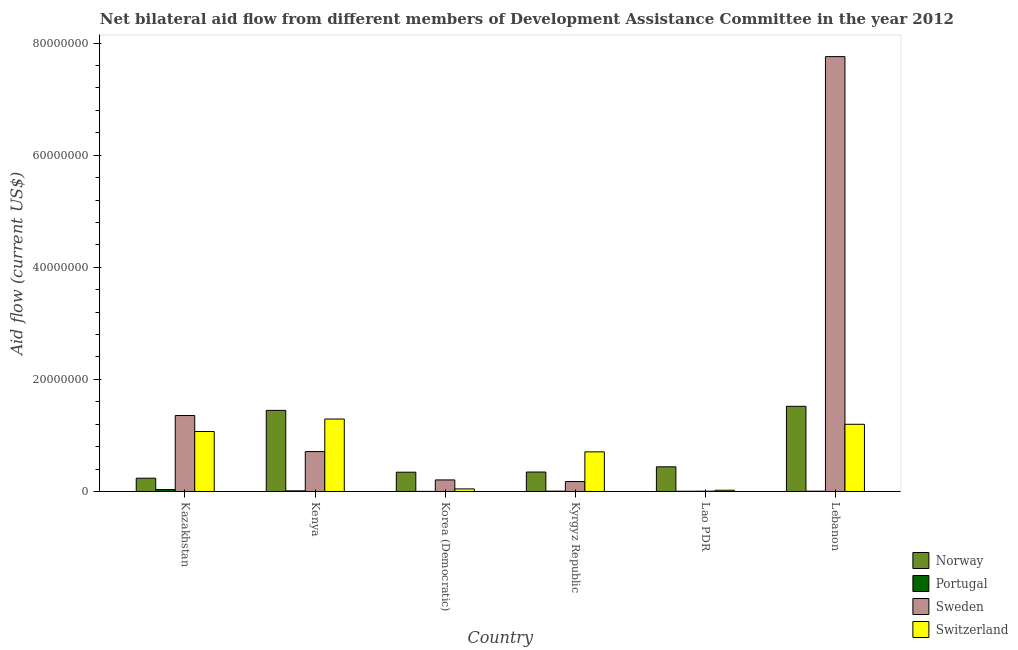Are the number of bars per tick equal to the number of legend labels?
Make the answer very short. Yes. How many bars are there on the 6th tick from the left?
Offer a terse response. 4. How many bars are there on the 5th tick from the right?
Your answer should be compact. 4. What is the label of the 4th group of bars from the left?
Ensure brevity in your answer.  Kyrgyz Republic. In how many cases, is the number of bars for a given country not equal to the number of legend labels?
Give a very brief answer. 0. What is the amount of aid given by sweden in Korea (Democratic)?
Give a very brief answer. 2.06e+06. Across all countries, what is the maximum amount of aid given by sweden?
Keep it short and to the point. 7.76e+07. Across all countries, what is the minimum amount of aid given by portugal?
Your answer should be compact. 10000. In which country was the amount of aid given by portugal maximum?
Keep it short and to the point. Kazakhstan. In which country was the amount of aid given by norway minimum?
Ensure brevity in your answer.  Kazakhstan. What is the total amount of aid given by sweden in the graph?
Offer a very short reply. 1.02e+08. What is the difference between the amount of aid given by portugal in Kenya and that in Kyrgyz Republic?
Your response must be concise. 5.00e+04. What is the difference between the amount of aid given by portugal in Kazakhstan and the amount of aid given by sweden in Kyrgyz Republic?
Offer a terse response. -1.43e+06. What is the average amount of aid given by sweden per country?
Make the answer very short. 1.70e+07. What is the difference between the amount of aid given by sweden and amount of aid given by switzerland in Kazakhstan?
Offer a very short reply. 2.85e+06. What is the ratio of the amount of aid given by norway in Kyrgyz Republic to that in Lebanon?
Your answer should be very brief. 0.23. Is the amount of aid given by sweden in Kazakhstan less than that in Lao PDR?
Give a very brief answer. No. What is the difference between the highest and the lowest amount of aid given by norway?
Offer a terse response. 1.28e+07. In how many countries, is the amount of aid given by switzerland greater than the average amount of aid given by switzerland taken over all countries?
Your response must be concise. 3. Is it the case that in every country, the sum of the amount of aid given by switzerland and amount of aid given by sweden is greater than the sum of amount of aid given by norway and amount of aid given by portugal?
Provide a succinct answer. No. What does the 2nd bar from the right in Lao PDR represents?
Provide a short and direct response. Sweden. How many bars are there?
Keep it short and to the point. 24. Are all the bars in the graph horizontal?
Offer a terse response. No. How many countries are there in the graph?
Keep it short and to the point. 6. Are the values on the major ticks of Y-axis written in scientific E-notation?
Your answer should be very brief. No. Does the graph contain any zero values?
Give a very brief answer. No. Does the graph contain grids?
Give a very brief answer. No. Where does the legend appear in the graph?
Your answer should be very brief. Bottom right. How are the legend labels stacked?
Provide a succinct answer. Vertical. What is the title of the graph?
Your answer should be very brief. Net bilateral aid flow from different members of Development Assistance Committee in the year 2012. What is the Aid flow (current US$) in Norway in Kazakhstan?
Keep it short and to the point. 2.37e+06. What is the Aid flow (current US$) of Sweden in Kazakhstan?
Offer a terse response. 1.36e+07. What is the Aid flow (current US$) of Switzerland in Kazakhstan?
Provide a succinct answer. 1.07e+07. What is the Aid flow (current US$) in Norway in Kenya?
Provide a short and direct response. 1.45e+07. What is the Aid flow (current US$) of Sweden in Kenya?
Your answer should be very brief. 7.12e+06. What is the Aid flow (current US$) of Switzerland in Kenya?
Provide a succinct answer. 1.29e+07. What is the Aid flow (current US$) of Norway in Korea (Democratic)?
Provide a short and direct response. 3.44e+06. What is the Aid flow (current US$) of Sweden in Korea (Democratic)?
Provide a succinct answer. 2.06e+06. What is the Aid flow (current US$) in Switzerland in Korea (Democratic)?
Offer a terse response. 4.60e+05. What is the Aid flow (current US$) in Norway in Kyrgyz Republic?
Make the answer very short. 3.47e+06. What is the Aid flow (current US$) in Sweden in Kyrgyz Republic?
Provide a short and direct response. 1.77e+06. What is the Aid flow (current US$) of Switzerland in Kyrgyz Republic?
Keep it short and to the point. 7.07e+06. What is the Aid flow (current US$) of Norway in Lao PDR?
Offer a terse response. 4.40e+06. What is the Aid flow (current US$) of Sweden in Lao PDR?
Give a very brief answer. 5.00e+04. What is the Aid flow (current US$) in Norway in Lebanon?
Your response must be concise. 1.52e+07. What is the Aid flow (current US$) in Sweden in Lebanon?
Offer a very short reply. 7.76e+07. What is the Aid flow (current US$) of Switzerland in Lebanon?
Make the answer very short. 1.20e+07. Across all countries, what is the maximum Aid flow (current US$) of Norway?
Offer a terse response. 1.52e+07. Across all countries, what is the maximum Aid flow (current US$) of Sweden?
Ensure brevity in your answer.  7.76e+07. Across all countries, what is the maximum Aid flow (current US$) in Switzerland?
Give a very brief answer. 1.29e+07. Across all countries, what is the minimum Aid flow (current US$) in Norway?
Your answer should be very brief. 2.37e+06. Across all countries, what is the minimum Aid flow (current US$) in Sweden?
Provide a succinct answer. 5.00e+04. Across all countries, what is the minimum Aid flow (current US$) of Switzerland?
Your response must be concise. 2.20e+05. What is the total Aid flow (current US$) of Norway in the graph?
Make the answer very short. 4.34e+07. What is the total Aid flow (current US$) of Sweden in the graph?
Provide a succinct answer. 1.02e+08. What is the total Aid flow (current US$) in Switzerland in the graph?
Your answer should be very brief. 4.34e+07. What is the difference between the Aid flow (current US$) of Norway in Kazakhstan and that in Kenya?
Provide a succinct answer. -1.21e+07. What is the difference between the Aid flow (current US$) in Portugal in Kazakhstan and that in Kenya?
Make the answer very short. 2.30e+05. What is the difference between the Aid flow (current US$) of Sweden in Kazakhstan and that in Kenya?
Your answer should be compact. 6.43e+06. What is the difference between the Aid flow (current US$) in Switzerland in Kazakhstan and that in Kenya?
Make the answer very short. -2.23e+06. What is the difference between the Aid flow (current US$) in Norway in Kazakhstan and that in Korea (Democratic)?
Keep it short and to the point. -1.07e+06. What is the difference between the Aid flow (current US$) in Portugal in Kazakhstan and that in Korea (Democratic)?
Give a very brief answer. 3.30e+05. What is the difference between the Aid flow (current US$) of Sweden in Kazakhstan and that in Korea (Democratic)?
Provide a short and direct response. 1.15e+07. What is the difference between the Aid flow (current US$) of Switzerland in Kazakhstan and that in Korea (Democratic)?
Your response must be concise. 1.02e+07. What is the difference between the Aid flow (current US$) of Norway in Kazakhstan and that in Kyrgyz Republic?
Give a very brief answer. -1.10e+06. What is the difference between the Aid flow (current US$) in Portugal in Kazakhstan and that in Kyrgyz Republic?
Your answer should be very brief. 2.80e+05. What is the difference between the Aid flow (current US$) in Sweden in Kazakhstan and that in Kyrgyz Republic?
Ensure brevity in your answer.  1.18e+07. What is the difference between the Aid flow (current US$) in Switzerland in Kazakhstan and that in Kyrgyz Republic?
Offer a terse response. 3.63e+06. What is the difference between the Aid flow (current US$) in Norway in Kazakhstan and that in Lao PDR?
Offer a terse response. -2.03e+06. What is the difference between the Aid flow (current US$) of Portugal in Kazakhstan and that in Lao PDR?
Your response must be concise. 3.00e+05. What is the difference between the Aid flow (current US$) of Sweden in Kazakhstan and that in Lao PDR?
Provide a short and direct response. 1.35e+07. What is the difference between the Aid flow (current US$) in Switzerland in Kazakhstan and that in Lao PDR?
Offer a terse response. 1.05e+07. What is the difference between the Aid flow (current US$) of Norway in Kazakhstan and that in Lebanon?
Provide a short and direct response. -1.28e+07. What is the difference between the Aid flow (current US$) in Sweden in Kazakhstan and that in Lebanon?
Offer a very short reply. -6.40e+07. What is the difference between the Aid flow (current US$) in Switzerland in Kazakhstan and that in Lebanon?
Ensure brevity in your answer.  -1.29e+06. What is the difference between the Aid flow (current US$) in Norway in Kenya and that in Korea (Democratic)?
Your response must be concise. 1.10e+07. What is the difference between the Aid flow (current US$) of Portugal in Kenya and that in Korea (Democratic)?
Ensure brevity in your answer.  1.00e+05. What is the difference between the Aid flow (current US$) in Sweden in Kenya and that in Korea (Democratic)?
Your answer should be very brief. 5.06e+06. What is the difference between the Aid flow (current US$) of Switzerland in Kenya and that in Korea (Democratic)?
Offer a very short reply. 1.25e+07. What is the difference between the Aid flow (current US$) of Norway in Kenya and that in Kyrgyz Republic?
Offer a very short reply. 1.10e+07. What is the difference between the Aid flow (current US$) in Sweden in Kenya and that in Kyrgyz Republic?
Make the answer very short. 5.35e+06. What is the difference between the Aid flow (current US$) of Switzerland in Kenya and that in Kyrgyz Republic?
Make the answer very short. 5.86e+06. What is the difference between the Aid flow (current US$) of Norway in Kenya and that in Lao PDR?
Provide a succinct answer. 1.01e+07. What is the difference between the Aid flow (current US$) of Portugal in Kenya and that in Lao PDR?
Your answer should be compact. 7.00e+04. What is the difference between the Aid flow (current US$) in Sweden in Kenya and that in Lao PDR?
Your answer should be very brief. 7.07e+06. What is the difference between the Aid flow (current US$) of Switzerland in Kenya and that in Lao PDR?
Keep it short and to the point. 1.27e+07. What is the difference between the Aid flow (current US$) of Norway in Kenya and that in Lebanon?
Offer a very short reply. -7.30e+05. What is the difference between the Aid flow (current US$) of Sweden in Kenya and that in Lebanon?
Provide a succinct answer. -7.05e+07. What is the difference between the Aid flow (current US$) in Switzerland in Kenya and that in Lebanon?
Provide a short and direct response. 9.40e+05. What is the difference between the Aid flow (current US$) in Switzerland in Korea (Democratic) and that in Kyrgyz Republic?
Provide a succinct answer. -6.61e+06. What is the difference between the Aid flow (current US$) in Norway in Korea (Democratic) and that in Lao PDR?
Keep it short and to the point. -9.60e+05. What is the difference between the Aid flow (current US$) in Portugal in Korea (Democratic) and that in Lao PDR?
Provide a short and direct response. -3.00e+04. What is the difference between the Aid flow (current US$) in Sweden in Korea (Democratic) and that in Lao PDR?
Your answer should be very brief. 2.01e+06. What is the difference between the Aid flow (current US$) in Norway in Korea (Democratic) and that in Lebanon?
Offer a very short reply. -1.18e+07. What is the difference between the Aid flow (current US$) of Sweden in Korea (Democratic) and that in Lebanon?
Give a very brief answer. -7.55e+07. What is the difference between the Aid flow (current US$) of Switzerland in Korea (Democratic) and that in Lebanon?
Give a very brief answer. -1.15e+07. What is the difference between the Aid flow (current US$) of Norway in Kyrgyz Republic and that in Lao PDR?
Your response must be concise. -9.30e+05. What is the difference between the Aid flow (current US$) in Portugal in Kyrgyz Republic and that in Lao PDR?
Your answer should be compact. 2.00e+04. What is the difference between the Aid flow (current US$) in Sweden in Kyrgyz Republic and that in Lao PDR?
Your response must be concise. 1.72e+06. What is the difference between the Aid flow (current US$) in Switzerland in Kyrgyz Republic and that in Lao PDR?
Your answer should be very brief. 6.85e+06. What is the difference between the Aid flow (current US$) in Norway in Kyrgyz Republic and that in Lebanon?
Provide a short and direct response. -1.17e+07. What is the difference between the Aid flow (current US$) in Sweden in Kyrgyz Republic and that in Lebanon?
Keep it short and to the point. -7.58e+07. What is the difference between the Aid flow (current US$) of Switzerland in Kyrgyz Republic and that in Lebanon?
Your answer should be compact. -4.92e+06. What is the difference between the Aid flow (current US$) of Norway in Lao PDR and that in Lebanon?
Keep it short and to the point. -1.08e+07. What is the difference between the Aid flow (current US$) of Sweden in Lao PDR and that in Lebanon?
Your answer should be compact. -7.76e+07. What is the difference between the Aid flow (current US$) of Switzerland in Lao PDR and that in Lebanon?
Your answer should be very brief. -1.18e+07. What is the difference between the Aid flow (current US$) of Norway in Kazakhstan and the Aid flow (current US$) of Portugal in Kenya?
Make the answer very short. 2.26e+06. What is the difference between the Aid flow (current US$) in Norway in Kazakhstan and the Aid flow (current US$) in Sweden in Kenya?
Your response must be concise. -4.75e+06. What is the difference between the Aid flow (current US$) in Norway in Kazakhstan and the Aid flow (current US$) in Switzerland in Kenya?
Give a very brief answer. -1.06e+07. What is the difference between the Aid flow (current US$) in Portugal in Kazakhstan and the Aid flow (current US$) in Sweden in Kenya?
Keep it short and to the point. -6.78e+06. What is the difference between the Aid flow (current US$) of Portugal in Kazakhstan and the Aid flow (current US$) of Switzerland in Kenya?
Provide a succinct answer. -1.26e+07. What is the difference between the Aid flow (current US$) of Sweden in Kazakhstan and the Aid flow (current US$) of Switzerland in Kenya?
Make the answer very short. 6.20e+05. What is the difference between the Aid flow (current US$) in Norway in Kazakhstan and the Aid flow (current US$) in Portugal in Korea (Democratic)?
Your response must be concise. 2.36e+06. What is the difference between the Aid flow (current US$) of Norway in Kazakhstan and the Aid flow (current US$) of Switzerland in Korea (Democratic)?
Your answer should be compact. 1.91e+06. What is the difference between the Aid flow (current US$) in Portugal in Kazakhstan and the Aid flow (current US$) in Sweden in Korea (Democratic)?
Provide a short and direct response. -1.72e+06. What is the difference between the Aid flow (current US$) in Portugal in Kazakhstan and the Aid flow (current US$) in Switzerland in Korea (Democratic)?
Provide a succinct answer. -1.20e+05. What is the difference between the Aid flow (current US$) in Sweden in Kazakhstan and the Aid flow (current US$) in Switzerland in Korea (Democratic)?
Provide a succinct answer. 1.31e+07. What is the difference between the Aid flow (current US$) of Norway in Kazakhstan and the Aid flow (current US$) of Portugal in Kyrgyz Republic?
Keep it short and to the point. 2.31e+06. What is the difference between the Aid flow (current US$) of Norway in Kazakhstan and the Aid flow (current US$) of Switzerland in Kyrgyz Republic?
Make the answer very short. -4.70e+06. What is the difference between the Aid flow (current US$) of Portugal in Kazakhstan and the Aid flow (current US$) of Sweden in Kyrgyz Republic?
Your response must be concise. -1.43e+06. What is the difference between the Aid flow (current US$) of Portugal in Kazakhstan and the Aid flow (current US$) of Switzerland in Kyrgyz Republic?
Your answer should be very brief. -6.73e+06. What is the difference between the Aid flow (current US$) in Sweden in Kazakhstan and the Aid flow (current US$) in Switzerland in Kyrgyz Republic?
Give a very brief answer. 6.48e+06. What is the difference between the Aid flow (current US$) of Norway in Kazakhstan and the Aid flow (current US$) of Portugal in Lao PDR?
Your response must be concise. 2.33e+06. What is the difference between the Aid flow (current US$) of Norway in Kazakhstan and the Aid flow (current US$) of Sweden in Lao PDR?
Keep it short and to the point. 2.32e+06. What is the difference between the Aid flow (current US$) of Norway in Kazakhstan and the Aid flow (current US$) of Switzerland in Lao PDR?
Ensure brevity in your answer.  2.15e+06. What is the difference between the Aid flow (current US$) in Portugal in Kazakhstan and the Aid flow (current US$) in Sweden in Lao PDR?
Your response must be concise. 2.90e+05. What is the difference between the Aid flow (current US$) in Sweden in Kazakhstan and the Aid flow (current US$) in Switzerland in Lao PDR?
Make the answer very short. 1.33e+07. What is the difference between the Aid flow (current US$) in Norway in Kazakhstan and the Aid flow (current US$) in Portugal in Lebanon?
Offer a very short reply. 2.32e+06. What is the difference between the Aid flow (current US$) in Norway in Kazakhstan and the Aid flow (current US$) in Sweden in Lebanon?
Make the answer very short. -7.52e+07. What is the difference between the Aid flow (current US$) of Norway in Kazakhstan and the Aid flow (current US$) of Switzerland in Lebanon?
Your answer should be very brief. -9.62e+06. What is the difference between the Aid flow (current US$) in Portugal in Kazakhstan and the Aid flow (current US$) in Sweden in Lebanon?
Ensure brevity in your answer.  -7.73e+07. What is the difference between the Aid flow (current US$) of Portugal in Kazakhstan and the Aid flow (current US$) of Switzerland in Lebanon?
Give a very brief answer. -1.16e+07. What is the difference between the Aid flow (current US$) in Sweden in Kazakhstan and the Aid flow (current US$) in Switzerland in Lebanon?
Offer a very short reply. 1.56e+06. What is the difference between the Aid flow (current US$) of Norway in Kenya and the Aid flow (current US$) of Portugal in Korea (Democratic)?
Keep it short and to the point. 1.45e+07. What is the difference between the Aid flow (current US$) of Norway in Kenya and the Aid flow (current US$) of Sweden in Korea (Democratic)?
Your answer should be very brief. 1.24e+07. What is the difference between the Aid flow (current US$) of Norway in Kenya and the Aid flow (current US$) of Switzerland in Korea (Democratic)?
Offer a terse response. 1.40e+07. What is the difference between the Aid flow (current US$) in Portugal in Kenya and the Aid flow (current US$) in Sweden in Korea (Democratic)?
Provide a short and direct response. -1.95e+06. What is the difference between the Aid flow (current US$) of Portugal in Kenya and the Aid flow (current US$) of Switzerland in Korea (Democratic)?
Keep it short and to the point. -3.50e+05. What is the difference between the Aid flow (current US$) in Sweden in Kenya and the Aid flow (current US$) in Switzerland in Korea (Democratic)?
Keep it short and to the point. 6.66e+06. What is the difference between the Aid flow (current US$) of Norway in Kenya and the Aid flow (current US$) of Portugal in Kyrgyz Republic?
Provide a succinct answer. 1.44e+07. What is the difference between the Aid flow (current US$) of Norway in Kenya and the Aid flow (current US$) of Sweden in Kyrgyz Republic?
Offer a very short reply. 1.27e+07. What is the difference between the Aid flow (current US$) of Norway in Kenya and the Aid flow (current US$) of Switzerland in Kyrgyz Republic?
Your response must be concise. 7.40e+06. What is the difference between the Aid flow (current US$) in Portugal in Kenya and the Aid flow (current US$) in Sweden in Kyrgyz Republic?
Make the answer very short. -1.66e+06. What is the difference between the Aid flow (current US$) in Portugal in Kenya and the Aid flow (current US$) in Switzerland in Kyrgyz Republic?
Provide a short and direct response. -6.96e+06. What is the difference between the Aid flow (current US$) in Norway in Kenya and the Aid flow (current US$) in Portugal in Lao PDR?
Your answer should be very brief. 1.44e+07. What is the difference between the Aid flow (current US$) of Norway in Kenya and the Aid flow (current US$) of Sweden in Lao PDR?
Provide a short and direct response. 1.44e+07. What is the difference between the Aid flow (current US$) of Norway in Kenya and the Aid flow (current US$) of Switzerland in Lao PDR?
Offer a terse response. 1.42e+07. What is the difference between the Aid flow (current US$) of Portugal in Kenya and the Aid flow (current US$) of Switzerland in Lao PDR?
Provide a short and direct response. -1.10e+05. What is the difference between the Aid flow (current US$) in Sweden in Kenya and the Aid flow (current US$) in Switzerland in Lao PDR?
Your response must be concise. 6.90e+06. What is the difference between the Aid flow (current US$) in Norway in Kenya and the Aid flow (current US$) in Portugal in Lebanon?
Ensure brevity in your answer.  1.44e+07. What is the difference between the Aid flow (current US$) in Norway in Kenya and the Aid flow (current US$) in Sweden in Lebanon?
Your answer should be very brief. -6.31e+07. What is the difference between the Aid flow (current US$) in Norway in Kenya and the Aid flow (current US$) in Switzerland in Lebanon?
Your response must be concise. 2.48e+06. What is the difference between the Aid flow (current US$) in Portugal in Kenya and the Aid flow (current US$) in Sweden in Lebanon?
Keep it short and to the point. -7.75e+07. What is the difference between the Aid flow (current US$) of Portugal in Kenya and the Aid flow (current US$) of Switzerland in Lebanon?
Offer a very short reply. -1.19e+07. What is the difference between the Aid flow (current US$) of Sweden in Kenya and the Aid flow (current US$) of Switzerland in Lebanon?
Give a very brief answer. -4.87e+06. What is the difference between the Aid flow (current US$) of Norway in Korea (Democratic) and the Aid flow (current US$) of Portugal in Kyrgyz Republic?
Offer a terse response. 3.38e+06. What is the difference between the Aid flow (current US$) of Norway in Korea (Democratic) and the Aid flow (current US$) of Sweden in Kyrgyz Republic?
Offer a terse response. 1.67e+06. What is the difference between the Aid flow (current US$) of Norway in Korea (Democratic) and the Aid flow (current US$) of Switzerland in Kyrgyz Republic?
Offer a terse response. -3.63e+06. What is the difference between the Aid flow (current US$) in Portugal in Korea (Democratic) and the Aid flow (current US$) in Sweden in Kyrgyz Republic?
Keep it short and to the point. -1.76e+06. What is the difference between the Aid flow (current US$) in Portugal in Korea (Democratic) and the Aid flow (current US$) in Switzerland in Kyrgyz Republic?
Provide a succinct answer. -7.06e+06. What is the difference between the Aid flow (current US$) of Sweden in Korea (Democratic) and the Aid flow (current US$) of Switzerland in Kyrgyz Republic?
Your answer should be compact. -5.01e+06. What is the difference between the Aid flow (current US$) in Norway in Korea (Democratic) and the Aid flow (current US$) in Portugal in Lao PDR?
Offer a very short reply. 3.40e+06. What is the difference between the Aid flow (current US$) in Norway in Korea (Democratic) and the Aid flow (current US$) in Sweden in Lao PDR?
Offer a terse response. 3.39e+06. What is the difference between the Aid flow (current US$) in Norway in Korea (Democratic) and the Aid flow (current US$) in Switzerland in Lao PDR?
Your answer should be very brief. 3.22e+06. What is the difference between the Aid flow (current US$) in Portugal in Korea (Democratic) and the Aid flow (current US$) in Switzerland in Lao PDR?
Offer a very short reply. -2.10e+05. What is the difference between the Aid flow (current US$) of Sweden in Korea (Democratic) and the Aid flow (current US$) of Switzerland in Lao PDR?
Offer a terse response. 1.84e+06. What is the difference between the Aid flow (current US$) in Norway in Korea (Democratic) and the Aid flow (current US$) in Portugal in Lebanon?
Your answer should be very brief. 3.39e+06. What is the difference between the Aid flow (current US$) in Norway in Korea (Democratic) and the Aid flow (current US$) in Sweden in Lebanon?
Give a very brief answer. -7.42e+07. What is the difference between the Aid flow (current US$) of Norway in Korea (Democratic) and the Aid flow (current US$) of Switzerland in Lebanon?
Provide a succinct answer. -8.55e+06. What is the difference between the Aid flow (current US$) in Portugal in Korea (Democratic) and the Aid flow (current US$) in Sweden in Lebanon?
Your answer should be compact. -7.76e+07. What is the difference between the Aid flow (current US$) of Portugal in Korea (Democratic) and the Aid flow (current US$) of Switzerland in Lebanon?
Offer a terse response. -1.20e+07. What is the difference between the Aid flow (current US$) of Sweden in Korea (Democratic) and the Aid flow (current US$) of Switzerland in Lebanon?
Your answer should be very brief. -9.93e+06. What is the difference between the Aid flow (current US$) of Norway in Kyrgyz Republic and the Aid flow (current US$) of Portugal in Lao PDR?
Give a very brief answer. 3.43e+06. What is the difference between the Aid flow (current US$) in Norway in Kyrgyz Republic and the Aid flow (current US$) in Sweden in Lao PDR?
Your response must be concise. 3.42e+06. What is the difference between the Aid flow (current US$) of Norway in Kyrgyz Republic and the Aid flow (current US$) of Switzerland in Lao PDR?
Offer a very short reply. 3.25e+06. What is the difference between the Aid flow (current US$) of Portugal in Kyrgyz Republic and the Aid flow (current US$) of Sweden in Lao PDR?
Provide a short and direct response. 10000. What is the difference between the Aid flow (current US$) of Portugal in Kyrgyz Republic and the Aid flow (current US$) of Switzerland in Lao PDR?
Your answer should be compact. -1.60e+05. What is the difference between the Aid flow (current US$) in Sweden in Kyrgyz Republic and the Aid flow (current US$) in Switzerland in Lao PDR?
Ensure brevity in your answer.  1.55e+06. What is the difference between the Aid flow (current US$) in Norway in Kyrgyz Republic and the Aid flow (current US$) in Portugal in Lebanon?
Your response must be concise. 3.42e+06. What is the difference between the Aid flow (current US$) in Norway in Kyrgyz Republic and the Aid flow (current US$) in Sweden in Lebanon?
Provide a short and direct response. -7.41e+07. What is the difference between the Aid flow (current US$) of Norway in Kyrgyz Republic and the Aid flow (current US$) of Switzerland in Lebanon?
Ensure brevity in your answer.  -8.52e+06. What is the difference between the Aid flow (current US$) of Portugal in Kyrgyz Republic and the Aid flow (current US$) of Sweden in Lebanon?
Keep it short and to the point. -7.75e+07. What is the difference between the Aid flow (current US$) in Portugal in Kyrgyz Republic and the Aid flow (current US$) in Switzerland in Lebanon?
Your answer should be very brief. -1.19e+07. What is the difference between the Aid flow (current US$) of Sweden in Kyrgyz Republic and the Aid flow (current US$) of Switzerland in Lebanon?
Make the answer very short. -1.02e+07. What is the difference between the Aid flow (current US$) in Norway in Lao PDR and the Aid flow (current US$) in Portugal in Lebanon?
Offer a very short reply. 4.35e+06. What is the difference between the Aid flow (current US$) in Norway in Lao PDR and the Aid flow (current US$) in Sweden in Lebanon?
Offer a terse response. -7.32e+07. What is the difference between the Aid flow (current US$) in Norway in Lao PDR and the Aid flow (current US$) in Switzerland in Lebanon?
Your answer should be compact. -7.59e+06. What is the difference between the Aid flow (current US$) in Portugal in Lao PDR and the Aid flow (current US$) in Sweden in Lebanon?
Provide a short and direct response. -7.76e+07. What is the difference between the Aid flow (current US$) of Portugal in Lao PDR and the Aid flow (current US$) of Switzerland in Lebanon?
Offer a very short reply. -1.20e+07. What is the difference between the Aid flow (current US$) of Sweden in Lao PDR and the Aid flow (current US$) of Switzerland in Lebanon?
Ensure brevity in your answer.  -1.19e+07. What is the average Aid flow (current US$) in Norway per country?
Give a very brief answer. 7.22e+06. What is the average Aid flow (current US$) of Portugal per country?
Provide a succinct answer. 1.02e+05. What is the average Aid flow (current US$) in Sweden per country?
Provide a succinct answer. 1.70e+07. What is the average Aid flow (current US$) in Switzerland per country?
Your answer should be compact. 7.23e+06. What is the difference between the Aid flow (current US$) of Norway and Aid flow (current US$) of Portugal in Kazakhstan?
Offer a very short reply. 2.03e+06. What is the difference between the Aid flow (current US$) in Norway and Aid flow (current US$) in Sweden in Kazakhstan?
Your response must be concise. -1.12e+07. What is the difference between the Aid flow (current US$) of Norway and Aid flow (current US$) of Switzerland in Kazakhstan?
Keep it short and to the point. -8.33e+06. What is the difference between the Aid flow (current US$) in Portugal and Aid flow (current US$) in Sweden in Kazakhstan?
Your answer should be compact. -1.32e+07. What is the difference between the Aid flow (current US$) of Portugal and Aid flow (current US$) of Switzerland in Kazakhstan?
Ensure brevity in your answer.  -1.04e+07. What is the difference between the Aid flow (current US$) of Sweden and Aid flow (current US$) of Switzerland in Kazakhstan?
Your response must be concise. 2.85e+06. What is the difference between the Aid flow (current US$) of Norway and Aid flow (current US$) of Portugal in Kenya?
Your answer should be compact. 1.44e+07. What is the difference between the Aid flow (current US$) of Norway and Aid flow (current US$) of Sweden in Kenya?
Provide a succinct answer. 7.35e+06. What is the difference between the Aid flow (current US$) in Norway and Aid flow (current US$) in Switzerland in Kenya?
Offer a terse response. 1.54e+06. What is the difference between the Aid flow (current US$) in Portugal and Aid flow (current US$) in Sweden in Kenya?
Your answer should be very brief. -7.01e+06. What is the difference between the Aid flow (current US$) in Portugal and Aid flow (current US$) in Switzerland in Kenya?
Keep it short and to the point. -1.28e+07. What is the difference between the Aid flow (current US$) in Sweden and Aid flow (current US$) in Switzerland in Kenya?
Offer a terse response. -5.81e+06. What is the difference between the Aid flow (current US$) of Norway and Aid flow (current US$) of Portugal in Korea (Democratic)?
Provide a succinct answer. 3.43e+06. What is the difference between the Aid flow (current US$) in Norway and Aid flow (current US$) in Sweden in Korea (Democratic)?
Offer a terse response. 1.38e+06. What is the difference between the Aid flow (current US$) of Norway and Aid flow (current US$) of Switzerland in Korea (Democratic)?
Your answer should be compact. 2.98e+06. What is the difference between the Aid flow (current US$) in Portugal and Aid flow (current US$) in Sweden in Korea (Democratic)?
Give a very brief answer. -2.05e+06. What is the difference between the Aid flow (current US$) of Portugal and Aid flow (current US$) of Switzerland in Korea (Democratic)?
Provide a short and direct response. -4.50e+05. What is the difference between the Aid flow (current US$) in Sweden and Aid flow (current US$) in Switzerland in Korea (Democratic)?
Ensure brevity in your answer.  1.60e+06. What is the difference between the Aid flow (current US$) in Norway and Aid flow (current US$) in Portugal in Kyrgyz Republic?
Give a very brief answer. 3.41e+06. What is the difference between the Aid flow (current US$) of Norway and Aid flow (current US$) of Sweden in Kyrgyz Republic?
Ensure brevity in your answer.  1.70e+06. What is the difference between the Aid flow (current US$) in Norway and Aid flow (current US$) in Switzerland in Kyrgyz Republic?
Provide a short and direct response. -3.60e+06. What is the difference between the Aid flow (current US$) of Portugal and Aid flow (current US$) of Sweden in Kyrgyz Republic?
Make the answer very short. -1.71e+06. What is the difference between the Aid flow (current US$) of Portugal and Aid flow (current US$) of Switzerland in Kyrgyz Republic?
Provide a short and direct response. -7.01e+06. What is the difference between the Aid flow (current US$) in Sweden and Aid flow (current US$) in Switzerland in Kyrgyz Republic?
Offer a very short reply. -5.30e+06. What is the difference between the Aid flow (current US$) in Norway and Aid flow (current US$) in Portugal in Lao PDR?
Provide a succinct answer. 4.36e+06. What is the difference between the Aid flow (current US$) of Norway and Aid flow (current US$) of Sweden in Lao PDR?
Ensure brevity in your answer.  4.35e+06. What is the difference between the Aid flow (current US$) of Norway and Aid flow (current US$) of Switzerland in Lao PDR?
Keep it short and to the point. 4.18e+06. What is the difference between the Aid flow (current US$) in Portugal and Aid flow (current US$) in Switzerland in Lao PDR?
Your response must be concise. -1.80e+05. What is the difference between the Aid flow (current US$) in Sweden and Aid flow (current US$) in Switzerland in Lao PDR?
Provide a succinct answer. -1.70e+05. What is the difference between the Aid flow (current US$) of Norway and Aid flow (current US$) of Portugal in Lebanon?
Your answer should be compact. 1.52e+07. What is the difference between the Aid flow (current US$) of Norway and Aid flow (current US$) of Sweden in Lebanon?
Your answer should be compact. -6.24e+07. What is the difference between the Aid flow (current US$) in Norway and Aid flow (current US$) in Switzerland in Lebanon?
Your answer should be compact. 3.21e+06. What is the difference between the Aid flow (current US$) of Portugal and Aid flow (current US$) of Sweden in Lebanon?
Offer a very short reply. -7.76e+07. What is the difference between the Aid flow (current US$) in Portugal and Aid flow (current US$) in Switzerland in Lebanon?
Give a very brief answer. -1.19e+07. What is the difference between the Aid flow (current US$) of Sweden and Aid flow (current US$) of Switzerland in Lebanon?
Offer a terse response. 6.56e+07. What is the ratio of the Aid flow (current US$) in Norway in Kazakhstan to that in Kenya?
Provide a short and direct response. 0.16. What is the ratio of the Aid flow (current US$) of Portugal in Kazakhstan to that in Kenya?
Offer a very short reply. 3.09. What is the ratio of the Aid flow (current US$) of Sweden in Kazakhstan to that in Kenya?
Your response must be concise. 1.9. What is the ratio of the Aid flow (current US$) in Switzerland in Kazakhstan to that in Kenya?
Provide a short and direct response. 0.83. What is the ratio of the Aid flow (current US$) of Norway in Kazakhstan to that in Korea (Democratic)?
Keep it short and to the point. 0.69. What is the ratio of the Aid flow (current US$) of Sweden in Kazakhstan to that in Korea (Democratic)?
Offer a very short reply. 6.58. What is the ratio of the Aid flow (current US$) in Switzerland in Kazakhstan to that in Korea (Democratic)?
Offer a terse response. 23.26. What is the ratio of the Aid flow (current US$) in Norway in Kazakhstan to that in Kyrgyz Republic?
Keep it short and to the point. 0.68. What is the ratio of the Aid flow (current US$) of Portugal in Kazakhstan to that in Kyrgyz Republic?
Provide a succinct answer. 5.67. What is the ratio of the Aid flow (current US$) of Sweden in Kazakhstan to that in Kyrgyz Republic?
Offer a very short reply. 7.66. What is the ratio of the Aid flow (current US$) in Switzerland in Kazakhstan to that in Kyrgyz Republic?
Ensure brevity in your answer.  1.51. What is the ratio of the Aid flow (current US$) of Norway in Kazakhstan to that in Lao PDR?
Make the answer very short. 0.54. What is the ratio of the Aid flow (current US$) of Portugal in Kazakhstan to that in Lao PDR?
Ensure brevity in your answer.  8.5. What is the ratio of the Aid flow (current US$) of Sweden in Kazakhstan to that in Lao PDR?
Ensure brevity in your answer.  271. What is the ratio of the Aid flow (current US$) in Switzerland in Kazakhstan to that in Lao PDR?
Offer a terse response. 48.64. What is the ratio of the Aid flow (current US$) of Norway in Kazakhstan to that in Lebanon?
Offer a terse response. 0.16. What is the ratio of the Aid flow (current US$) in Sweden in Kazakhstan to that in Lebanon?
Ensure brevity in your answer.  0.17. What is the ratio of the Aid flow (current US$) in Switzerland in Kazakhstan to that in Lebanon?
Ensure brevity in your answer.  0.89. What is the ratio of the Aid flow (current US$) in Norway in Kenya to that in Korea (Democratic)?
Your answer should be very brief. 4.21. What is the ratio of the Aid flow (current US$) of Sweden in Kenya to that in Korea (Democratic)?
Your response must be concise. 3.46. What is the ratio of the Aid flow (current US$) in Switzerland in Kenya to that in Korea (Democratic)?
Ensure brevity in your answer.  28.11. What is the ratio of the Aid flow (current US$) of Norway in Kenya to that in Kyrgyz Republic?
Provide a succinct answer. 4.17. What is the ratio of the Aid flow (current US$) in Portugal in Kenya to that in Kyrgyz Republic?
Your answer should be very brief. 1.83. What is the ratio of the Aid flow (current US$) in Sweden in Kenya to that in Kyrgyz Republic?
Give a very brief answer. 4.02. What is the ratio of the Aid flow (current US$) in Switzerland in Kenya to that in Kyrgyz Republic?
Your answer should be compact. 1.83. What is the ratio of the Aid flow (current US$) in Norway in Kenya to that in Lao PDR?
Give a very brief answer. 3.29. What is the ratio of the Aid flow (current US$) in Portugal in Kenya to that in Lao PDR?
Your answer should be compact. 2.75. What is the ratio of the Aid flow (current US$) in Sweden in Kenya to that in Lao PDR?
Your answer should be compact. 142.4. What is the ratio of the Aid flow (current US$) in Switzerland in Kenya to that in Lao PDR?
Give a very brief answer. 58.77. What is the ratio of the Aid flow (current US$) of Norway in Kenya to that in Lebanon?
Your response must be concise. 0.95. What is the ratio of the Aid flow (current US$) of Portugal in Kenya to that in Lebanon?
Offer a very short reply. 2.2. What is the ratio of the Aid flow (current US$) in Sweden in Kenya to that in Lebanon?
Provide a short and direct response. 0.09. What is the ratio of the Aid flow (current US$) in Switzerland in Kenya to that in Lebanon?
Your answer should be compact. 1.08. What is the ratio of the Aid flow (current US$) of Norway in Korea (Democratic) to that in Kyrgyz Republic?
Make the answer very short. 0.99. What is the ratio of the Aid flow (current US$) of Sweden in Korea (Democratic) to that in Kyrgyz Republic?
Your answer should be compact. 1.16. What is the ratio of the Aid flow (current US$) of Switzerland in Korea (Democratic) to that in Kyrgyz Republic?
Your answer should be very brief. 0.07. What is the ratio of the Aid flow (current US$) of Norway in Korea (Democratic) to that in Lao PDR?
Give a very brief answer. 0.78. What is the ratio of the Aid flow (current US$) of Sweden in Korea (Democratic) to that in Lao PDR?
Your response must be concise. 41.2. What is the ratio of the Aid flow (current US$) in Switzerland in Korea (Democratic) to that in Lao PDR?
Offer a very short reply. 2.09. What is the ratio of the Aid flow (current US$) in Norway in Korea (Democratic) to that in Lebanon?
Provide a short and direct response. 0.23. What is the ratio of the Aid flow (current US$) of Portugal in Korea (Democratic) to that in Lebanon?
Offer a terse response. 0.2. What is the ratio of the Aid flow (current US$) in Sweden in Korea (Democratic) to that in Lebanon?
Provide a short and direct response. 0.03. What is the ratio of the Aid flow (current US$) of Switzerland in Korea (Democratic) to that in Lebanon?
Provide a short and direct response. 0.04. What is the ratio of the Aid flow (current US$) of Norway in Kyrgyz Republic to that in Lao PDR?
Offer a terse response. 0.79. What is the ratio of the Aid flow (current US$) of Sweden in Kyrgyz Republic to that in Lao PDR?
Ensure brevity in your answer.  35.4. What is the ratio of the Aid flow (current US$) in Switzerland in Kyrgyz Republic to that in Lao PDR?
Offer a very short reply. 32.14. What is the ratio of the Aid flow (current US$) in Norway in Kyrgyz Republic to that in Lebanon?
Provide a succinct answer. 0.23. What is the ratio of the Aid flow (current US$) in Portugal in Kyrgyz Republic to that in Lebanon?
Give a very brief answer. 1.2. What is the ratio of the Aid flow (current US$) in Sweden in Kyrgyz Republic to that in Lebanon?
Provide a short and direct response. 0.02. What is the ratio of the Aid flow (current US$) in Switzerland in Kyrgyz Republic to that in Lebanon?
Give a very brief answer. 0.59. What is the ratio of the Aid flow (current US$) of Norway in Lao PDR to that in Lebanon?
Provide a succinct answer. 0.29. What is the ratio of the Aid flow (current US$) of Sweden in Lao PDR to that in Lebanon?
Your answer should be compact. 0. What is the ratio of the Aid flow (current US$) of Switzerland in Lao PDR to that in Lebanon?
Give a very brief answer. 0.02. What is the difference between the highest and the second highest Aid flow (current US$) in Norway?
Provide a short and direct response. 7.30e+05. What is the difference between the highest and the second highest Aid flow (current US$) of Portugal?
Keep it short and to the point. 2.30e+05. What is the difference between the highest and the second highest Aid flow (current US$) of Sweden?
Your answer should be compact. 6.40e+07. What is the difference between the highest and the second highest Aid flow (current US$) in Switzerland?
Offer a very short reply. 9.40e+05. What is the difference between the highest and the lowest Aid flow (current US$) of Norway?
Offer a very short reply. 1.28e+07. What is the difference between the highest and the lowest Aid flow (current US$) in Portugal?
Your answer should be compact. 3.30e+05. What is the difference between the highest and the lowest Aid flow (current US$) of Sweden?
Ensure brevity in your answer.  7.76e+07. What is the difference between the highest and the lowest Aid flow (current US$) of Switzerland?
Your answer should be compact. 1.27e+07. 